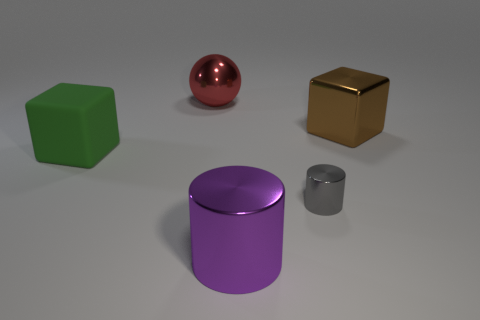Do the big green thing and the big object behind the brown block have the same shape?
Make the answer very short. No. What size is the other gray cylinder that is made of the same material as the large cylinder?
Your answer should be compact. Small. Are there any other things that are the same color as the sphere?
Offer a terse response. No. What material is the big purple cylinder in front of the big shiny thing that is behind the big block that is right of the big red shiny thing?
Provide a succinct answer. Metal. How many matte objects are big brown spheres or tiny gray objects?
Make the answer very short. 0. Is there any other thing that has the same material as the big green cube?
Provide a succinct answer. No. How many things are either green matte things or objects to the left of the small cylinder?
Your answer should be very brief. 3. There is a shiny thing that is right of the gray thing; does it have the same size as the large green matte thing?
Give a very brief answer. Yes. How many other things are there of the same shape as the large red shiny object?
Give a very brief answer. 0. How many blue objects are either tiny blocks or big metallic things?
Your answer should be very brief. 0. 